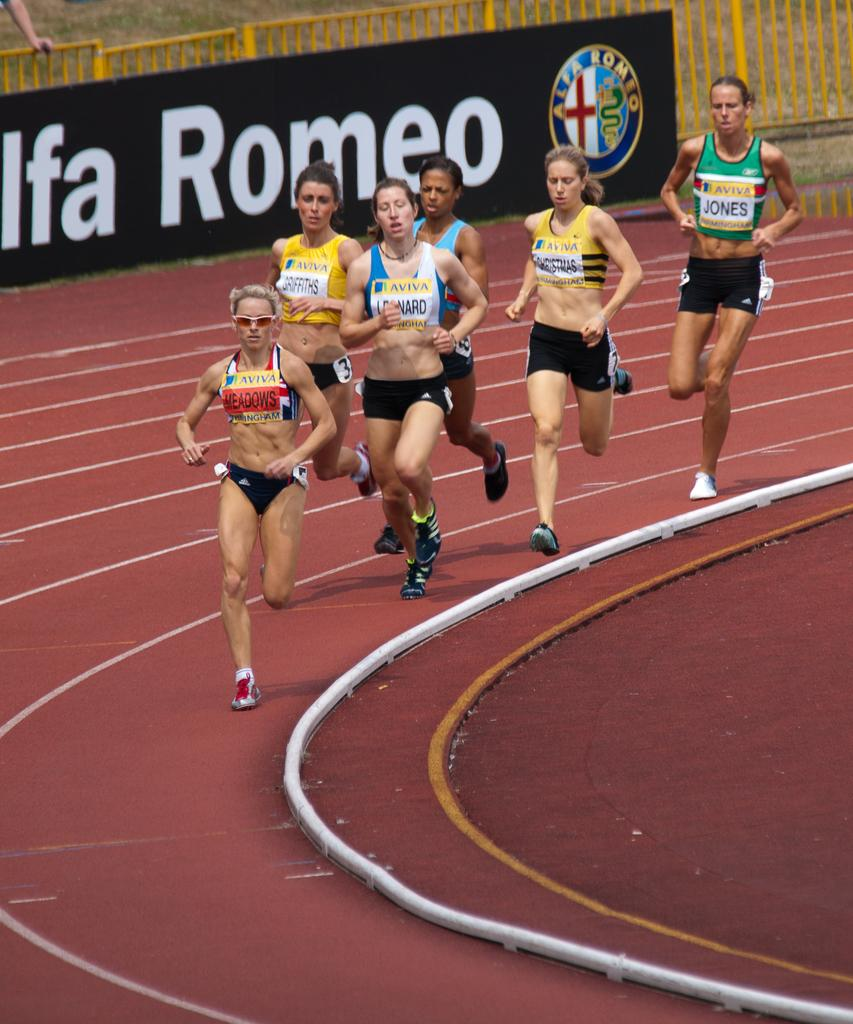What can be seen in the image? There is a group of girls in the image. What are the girls doing? The girls are running. What is at the top of the image? There is a board at the top of the image. What type of architectural feature can be seen in the image? There appears to be an iron railing in the image. What type of test is being conducted by the girls in the image? There is no indication in the image that the girls are conducting a test; they are simply running. 